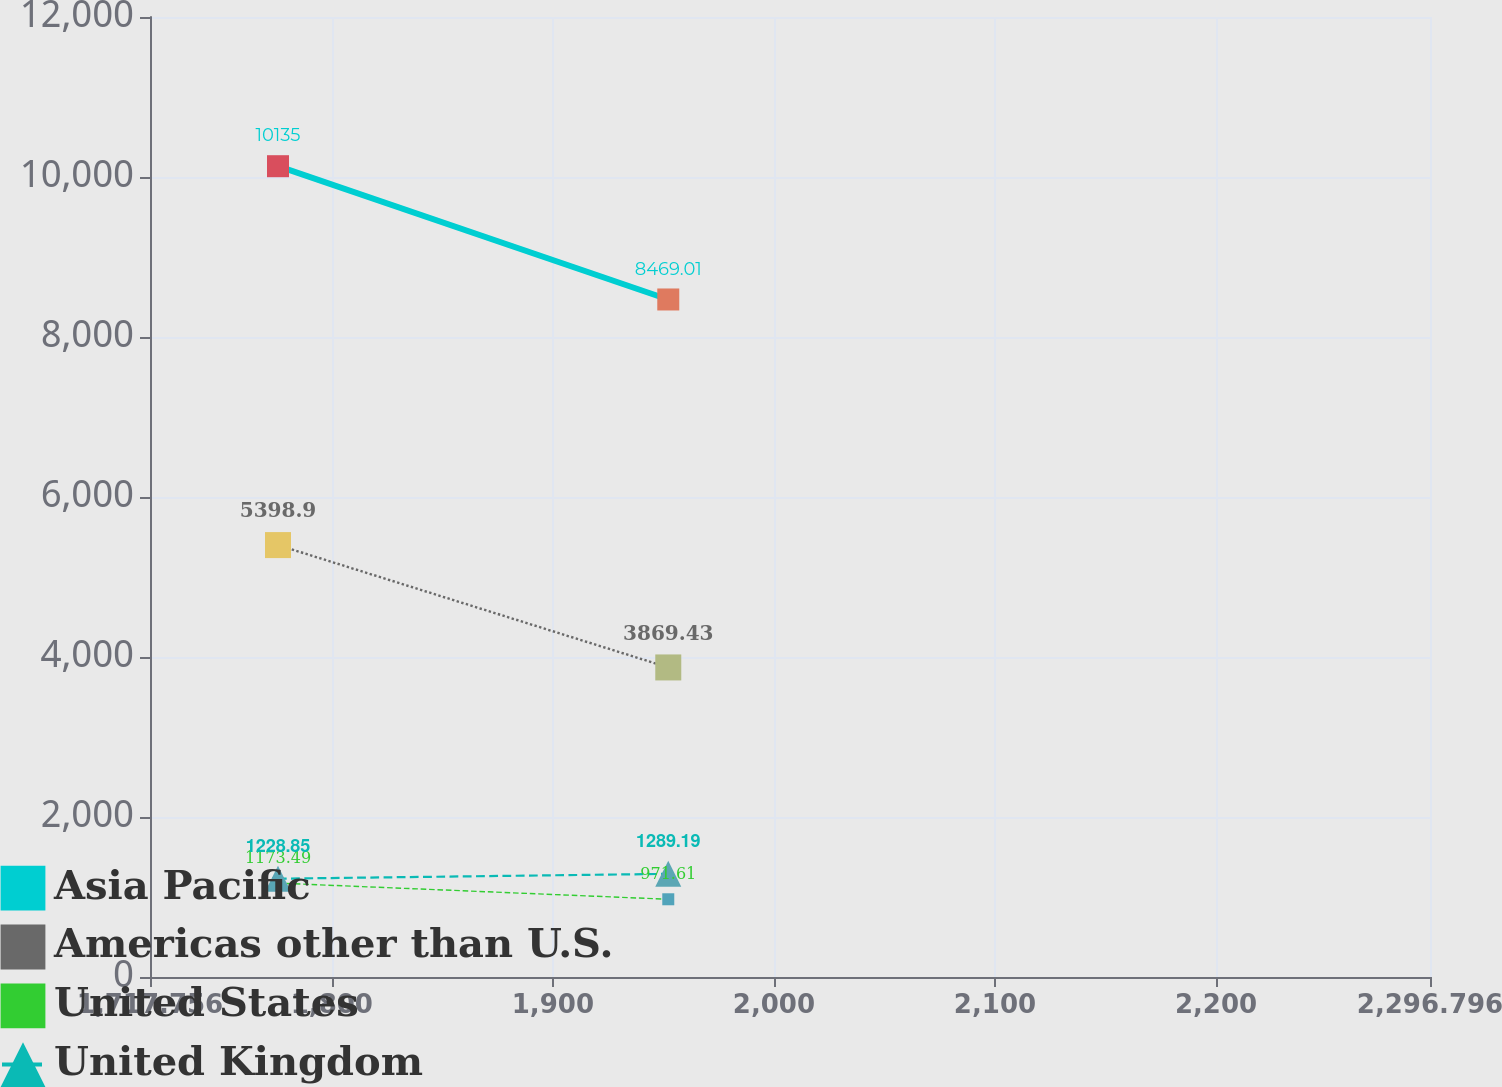<chart> <loc_0><loc_0><loc_500><loc_500><line_chart><ecel><fcel>Asia Pacific<fcel>Americas other than U.S.<fcel>United States<fcel>United Kingdom<nl><fcel>1775.66<fcel>10135<fcel>5398.9<fcel>1173.49<fcel>1228.85<nl><fcel>1952.21<fcel>8469.01<fcel>3869.43<fcel>971.61<fcel>1289.19<nl><fcel>2354.7<fcel>6922.03<fcel>2510.29<fcel>949.18<fcel>1440.01<nl></chart> 